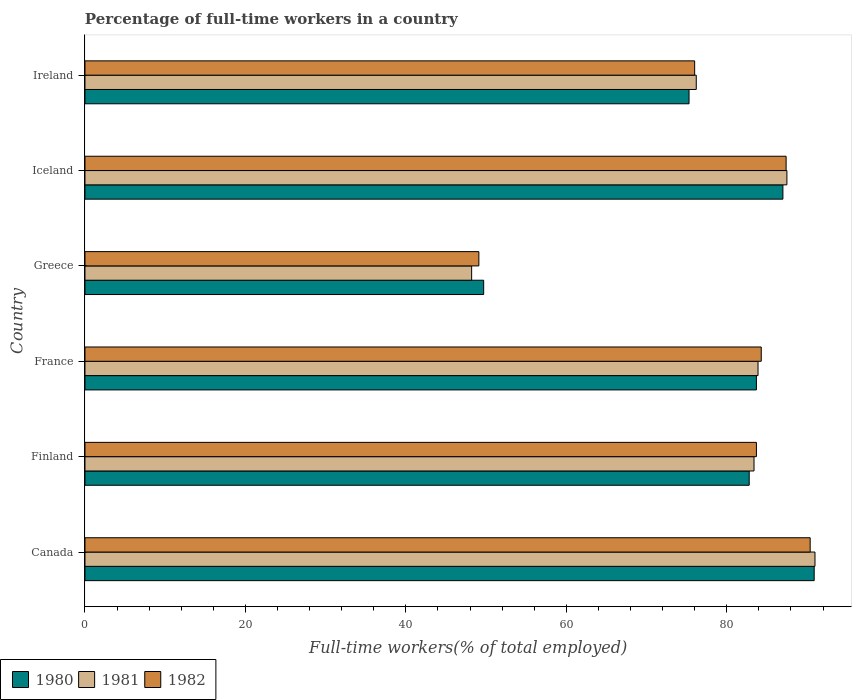How many different coloured bars are there?
Offer a terse response. 3. Are the number of bars per tick equal to the number of legend labels?
Offer a terse response. Yes. Are the number of bars on each tick of the Y-axis equal?
Provide a succinct answer. Yes. How many bars are there on the 1st tick from the top?
Your answer should be very brief. 3. What is the label of the 1st group of bars from the top?
Provide a short and direct response. Ireland. In how many cases, is the number of bars for a given country not equal to the number of legend labels?
Keep it short and to the point. 0. What is the percentage of full-time workers in 1982 in Finland?
Provide a succinct answer. 83.7. Across all countries, what is the maximum percentage of full-time workers in 1982?
Give a very brief answer. 90.4. Across all countries, what is the minimum percentage of full-time workers in 1980?
Offer a terse response. 49.7. In which country was the percentage of full-time workers in 1981 minimum?
Your answer should be very brief. Greece. What is the total percentage of full-time workers in 1982 in the graph?
Offer a very short reply. 470.9. What is the difference between the percentage of full-time workers in 1980 in Greece and that in Ireland?
Your answer should be very brief. -25.6. What is the average percentage of full-time workers in 1981 per country?
Make the answer very short. 78.37. What is the difference between the percentage of full-time workers in 1980 and percentage of full-time workers in 1981 in France?
Offer a very short reply. -0.2. What is the ratio of the percentage of full-time workers in 1981 in France to that in Greece?
Provide a short and direct response. 1.74. Is the percentage of full-time workers in 1980 in Greece less than that in Ireland?
Provide a succinct answer. Yes. What is the difference between the highest and the second highest percentage of full-time workers in 1980?
Your answer should be compact. 3.9. What is the difference between the highest and the lowest percentage of full-time workers in 1981?
Make the answer very short. 42.8. In how many countries, is the percentage of full-time workers in 1982 greater than the average percentage of full-time workers in 1982 taken over all countries?
Offer a very short reply. 4. What does the 1st bar from the bottom in Finland represents?
Provide a succinct answer. 1980. How many bars are there?
Provide a succinct answer. 18. Are all the bars in the graph horizontal?
Your answer should be very brief. Yes. Does the graph contain any zero values?
Ensure brevity in your answer.  No. Does the graph contain grids?
Ensure brevity in your answer.  No. Where does the legend appear in the graph?
Offer a very short reply. Bottom left. How are the legend labels stacked?
Your answer should be compact. Horizontal. What is the title of the graph?
Ensure brevity in your answer.  Percentage of full-time workers in a country. What is the label or title of the X-axis?
Offer a terse response. Full-time workers(% of total employed). What is the label or title of the Y-axis?
Keep it short and to the point. Country. What is the Full-time workers(% of total employed) in 1980 in Canada?
Give a very brief answer. 90.9. What is the Full-time workers(% of total employed) in 1981 in Canada?
Provide a succinct answer. 91. What is the Full-time workers(% of total employed) in 1982 in Canada?
Ensure brevity in your answer.  90.4. What is the Full-time workers(% of total employed) in 1980 in Finland?
Ensure brevity in your answer.  82.8. What is the Full-time workers(% of total employed) in 1981 in Finland?
Make the answer very short. 83.4. What is the Full-time workers(% of total employed) of 1982 in Finland?
Your answer should be very brief. 83.7. What is the Full-time workers(% of total employed) of 1980 in France?
Your response must be concise. 83.7. What is the Full-time workers(% of total employed) in 1981 in France?
Keep it short and to the point. 83.9. What is the Full-time workers(% of total employed) of 1982 in France?
Your answer should be compact. 84.3. What is the Full-time workers(% of total employed) of 1980 in Greece?
Give a very brief answer. 49.7. What is the Full-time workers(% of total employed) in 1981 in Greece?
Your response must be concise. 48.2. What is the Full-time workers(% of total employed) of 1982 in Greece?
Provide a succinct answer. 49.1. What is the Full-time workers(% of total employed) of 1980 in Iceland?
Provide a succinct answer. 87. What is the Full-time workers(% of total employed) in 1981 in Iceland?
Provide a short and direct response. 87.5. What is the Full-time workers(% of total employed) of 1982 in Iceland?
Keep it short and to the point. 87.4. What is the Full-time workers(% of total employed) of 1980 in Ireland?
Keep it short and to the point. 75.3. What is the Full-time workers(% of total employed) in 1981 in Ireland?
Offer a very short reply. 76.2. Across all countries, what is the maximum Full-time workers(% of total employed) in 1980?
Offer a very short reply. 90.9. Across all countries, what is the maximum Full-time workers(% of total employed) in 1981?
Your answer should be compact. 91. Across all countries, what is the maximum Full-time workers(% of total employed) in 1982?
Provide a succinct answer. 90.4. Across all countries, what is the minimum Full-time workers(% of total employed) of 1980?
Give a very brief answer. 49.7. Across all countries, what is the minimum Full-time workers(% of total employed) in 1981?
Keep it short and to the point. 48.2. Across all countries, what is the minimum Full-time workers(% of total employed) of 1982?
Offer a very short reply. 49.1. What is the total Full-time workers(% of total employed) of 1980 in the graph?
Ensure brevity in your answer.  469.4. What is the total Full-time workers(% of total employed) in 1981 in the graph?
Provide a short and direct response. 470.2. What is the total Full-time workers(% of total employed) of 1982 in the graph?
Make the answer very short. 470.9. What is the difference between the Full-time workers(% of total employed) in 1980 in Canada and that in Finland?
Provide a short and direct response. 8.1. What is the difference between the Full-time workers(% of total employed) of 1981 in Canada and that in Finland?
Give a very brief answer. 7.6. What is the difference between the Full-time workers(% of total employed) in 1982 in Canada and that in Finland?
Your response must be concise. 6.7. What is the difference between the Full-time workers(% of total employed) in 1980 in Canada and that in France?
Your answer should be compact. 7.2. What is the difference between the Full-time workers(% of total employed) in 1980 in Canada and that in Greece?
Provide a short and direct response. 41.2. What is the difference between the Full-time workers(% of total employed) of 1981 in Canada and that in Greece?
Provide a short and direct response. 42.8. What is the difference between the Full-time workers(% of total employed) in 1982 in Canada and that in Greece?
Make the answer very short. 41.3. What is the difference between the Full-time workers(% of total employed) in 1981 in Canada and that in Iceland?
Make the answer very short. 3.5. What is the difference between the Full-time workers(% of total employed) in 1982 in Canada and that in Iceland?
Offer a terse response. 3. What is the difference between the Full-time workers(% of total employed) of 1980 in Canada and that in Ireland?
Make the answer very short. 15.6. What is the difference between the Full-time workers(% of total employed) of 1980 in Finland and that in France?
Provide a short and direct response. -0.9. What is the difference between the Full-time workers(% of total employed) of 1981 in Finland and that in France?
Offer a terse response. -0.5. What is the difference between the Full-time workers(% of total employed) of 1980 in Finland and that in Greece?
Your answer should be very brief. 33.1. What is the difference between the Full-time workers(% of total employed) of 1981 in Finland and that in Greece?
Your answer should be compact. 35.2. What is the difference between the Full-time workers(% of total employed) of 1982 in Finland and that in Greece?
Provide a succinct answer. 34.6. What is the difference between the Full-time workers(% of total employed) of 1980 in Finland and that in Iceland?
Make the answer very short. -4.2. What is the difference between the Full-time workers(% of total employed) in 1981 in Finland and that in Iceland?
Provide a short and direct response. -4.1. What is the difference between the Full-time workers(% of total employed) of 1982 in Finland and that in Iceland?
Provide a succinct answer. -3.7. What is the difference between the Full-time workers(% of total employed) of 1981 in Finland and that in Ireland?
Offer a very short reply. 7.2. What is the difference between the Full-time workers(% of total employed) in 1981 in France and that in Greece?
Provide a short and direct response. 35.7. What is the difference between the Full-time workers(% of total employed) of 1982 in France and that in Greece?
Your answer should be compact. 35.2. What is the difference between the Full-time workers(% of total employed) in 1980 in France and that in Iceland?
Keep it short and to the point. -3.3. What is the difference between the Full-time workers(% of total employed) in 1981 in France and that in Iceland?
Give a very brief answer. -3.6. What is the difference between the Full-time workers(% of total employed) of 1980 in France and that in Ireland?
Your response must be concise. 8.4. What is the difference between the Full-time workers(% of total employed) in 1981 in France and that in Ireland?
Give a very brief answer. 7.7. What is the difference between the Full-time workers(% of total employed) in 1982 in France and that in Ireland?
Provide a short and direct response. 8.3. What is the difference between the Full-time workers(% of total employed) in 1980 in Greece and that in Iceland?
Your answer should be very brief. -37.3. What is the difference between the Full-time workers(% of total employed) in 1981 in Greece and that in Iceland?
Give a very brief answer. -39.3. What is the difference between the Full-time workers(% of total employed) of 1982 in Greece and that in Iceland?
Ensure brevity in your answer.  -38.3. What is the difference between the Full-time workers(% of total employed) of 1980 in Greece and that in Ireland?
Ensure brevity in your answer.  -25.6. What is the difference between the Full-time workers(% of total employed) of 1982 in Greece and that in Ireland?
Provide a short and direct response. -26.9. What is the difference between the Full-time workers(% of total employed) of 1980 in Iceland and that in Ireland?
Provide a short and direct response. 11.7. What is the difference between the Full-time workers(% of total employed) of 1982 in Iceland and that in Ireland?
Provide a short and direct response. 11.4. What is the difference between the Full-time workers(% of total employed) of 1981 in Canada and the Full-time workers(% of total employed) of 1982 in Finland?
Provide a succinct answer. 7.3. What is the difference between the Full-time workers(% of total employed) of 1980 in Canada and the Full-time workers(% of total employed) of 1982 in France?
Your response must be concise. 6.6. What is the difference between the Full-time workers(% of total employed) of 1981 in Canada and the Full-time workers(% of total employed) of 1982 in France?
Offer a very short reply. 6.7. What is the difference between the Full-time workers(% of total employed) of 1980 in Canada and the Full-time workers(% of total employed) of 1981 in Greece?
Offer a very short reply. 42.7. What is the difference between the Full-time workers(% of total employed) in 1980 in Canada and the Full-time workers(% of total employed) in 1982 in Greece?
Offer a very short reply. 41.8. What is the difference between the Full-time workers(% of total employed) in 1981 in Canada and the Full-time workers(% of total employed) in 1982 in Greece?
Make the answer very short. 41.9. What is the difference between the Full-time workers(% of total employed) in 1980 in Canada and the Full-time workers(% of total employed) in 1981 in Iceland?
Your answer should be compact. 3.4. What is the difference between the Full-time workers(% of total employed) in 1981 in Canada and the Full-time workers(% of total employed) in 1982 in Iceland?
Provide a succinct answer. 3.6. What is the difference between the Full-time workers(% of total employed) in 1980 in Canada and the Full-time workers(% of total employed) in 1982 in Ireland?
Your answer should be very brief. 14.9. What is the difference between the Full-time workers(% of total employed) in 1981 in Canada and the Full-time workers(% of total employed) in 1982 in Ireland?
Your response must be concise. 15. What is the difference between the Full-time workers(% of total employed) in 1980 in Finland and the Full-time workers(% of total employed) in 1981 in Greece?
Ensure brevity in your answer.  34.6. What is the difference between the Full-time workers(% of total employed) of 1980 in Finland and the Full-time workers(% of total employed) of 1982 in Greece?
Make the answer very short. 33.7. What is the difference between the Full-time workers(% of total employed) of 1981 in Finland and the Full-time workers(% of total employed) of 1982 in Greece?
Your answer should be compact. 34.3. What is the difference between the Full-time workers(% of total employed) in 1980 in Finland and the Full-time workers(% of total employed) in 1981 in Iceland?
Offer a very short reply. -4.7. What is the difference between the Full-time workers(% of total employed) of 1980 in Finland and the Full-time workers(% of total employed) of 1982 in Iceland?
Give a very brief answer. -4.6. What is the difference between the Full-time workers(% of total employed) of 1980 in France and the Full-time workers(% of total employed) of 1981 in Greece?
Keep it short and to the point. 35.5. What is the difference between the Full-time workers(% of total employed) of 1980 in France and the Full-time workers(% of total employed) of 1982 in Greece?
Offer a very short reply. 34.6. What is the difference between the Full-time workers(% of total employed) in 1981 in France and the Full-time workers(% of total employed) in 1982 in Greece?
Offer a very short reply. 34.8. What is the difference between the Full-time workers(% of total employed) of 1980 in France and the Full-time workers(% of total employed) of 1981 in Iceland?
Keep it short and to the point. -3.8. What is the difference between the Full-time workers(% of total employed) of 1980 in France and the Full-time workers(% of total employed) of 1982 in Iceland?
Provide a succinct answer. -3.7. What is the difference between the Full-time workers(% of total employed) in 1980 in France and the Full-time workers(% of total employed) in 1981 in Ireland?
Your answer should be compact. 7.5. What is the difference between the Full-time workers(% of total employed) of 1980 in Greece and the Full-time workers(% of total employed) of 1981 in Iceland?
Keep it short and to the point. -37.8. What is the difference between the Full-time workers(% of total employed) in 1980 in Greece and the Full-time workers(% of total employed) in 1982 in Iceland?
Offer a terse response. -37.7. What is the difference between the Full-time workers(% of total employed) of 1981 in Greece and the Full-time workers(% of total employed) of 1982 in Iceland?
Offer a very short reply. -39.2. What is the difference between the Full-time workers(% of total employed) in 1980 in Greece and the Full-time workers(% of total employed) in 1981 in Ireland?
Offer a very short reply. -26.5. What is the difference between the Full-time workers(% of total employed) in 1980 in Greece and the Full-time workers(% of total employed) in 1982 in Ireland?
Give a very brief answer. -26.3. What is the difference between the Full-time workers(% of total employed) of 1981 in Greece and the Full-time workers(% of total employed) of 1982 in Ireland?
Offer a terse response. -27.8. What is the difference between the Full-time workers(% of total employed) in 1980 in Iceland and the Full-time workers(% of total employed) in 1982 in Ireland?
Give a very brief answer. 11. What is the difference between the Full-time workers(% of total employed) of 1981 in Iceland and the Full-time workers(% of total employed) of 1982 in Ireland?
Give a very brief answer. 11.5. What is the average Full-time workers(% of total employed) of 1980 per country?
Give a very brief answer. 78.23. What is the average Full-time workers(% of total employed) in 1981 per country?
Offer a terse response. 78.37. What is the average Full-time workers(% of total employed) in 1982 per country?
Ensure brevity in your answer.  78.48. What is the difference between the Full-time workers(% of total employed) in 1980 and Full-time workers(% of total employed) in 1982 in Canada?
Give a very brief answer. 0.5. What is the difference between the Full-time workers(% of total employed) in 1981 and Full-time workers(% of total employed) in 1982 in Finland?
Provide a succinct answer. -0.3. What is the difference between the Full-time workers(% of total employed) in 1980 and Full-time workers(% of total employed) in 1981 in France?
Your answer should be very brief. -0.2. What is the difference between the Full-time workers(% of total employed) in 1981 and Full-time workers(% of total employed) in 1982 in France?
Offer a terse response. -0.4. What is the difference between the Full-time workers(% of total employed) of 1980 and Full-time workers(% of total employed) of 1981 in Iceland?
Provide a short and direct response. -0.5. What is the difference between the Full-time workers(% of total employed) of 1980 and Full-time workers(% of total employed) of 1982 in Iceland?
Your response must be concise. -0.4. What is the difference between the Full-time workers(% of total employed) in 1981 and Full-time workers(% of total employed) in 1982 in Iceland?
Give a very brief answer. 0.1. What is the difference between the Full-time workers(% of total employed) of 1980 and Full-time workers(% of total employed) of 1981 in Ireland?
Provide a short and direct response. -0.9. What is the difference between the Full-time workers(% of total employed) in 1981 and Full-time workers(% of total employed) in 1982 in Ireland?
Your answer should be compact. 0.2. What is the ratio of the Full-time workers(% of total employed) of 1980 in Canada to that in Finland?
Offer a terse response. 1.1. What is the ratio of the Full-time workers(% of total employed) in 1981 in Canada to that in Finland?
Offer a terse response. 1.09. What is the ratio of the Full-time workers(% of total employed) in 1980 in Canada to that in France?
Make the answer very short. 1.09. What is the ratio of the Full-time workers(% of total employed) of 1981 in Canada to that in France?
Your answer should be very brief. 1.08. What is the ratio of the Full-time workers(% of total employed) of 1982 in Canada to that in France?
Provide a succinct answer. 1.07. What is the ratio of the Full-time workers(% of total employed) of 1980 in Canada to that in Greece?
Offer a very short reply. 1.83. What is the ratio of the Full-time workers(% of total employed) of 1981 in Canada to that in Greece?
Provide a short and direct response. 1.89. What is the ratio of the Full-time workers(% of total employed) of 1982 in Canada to that in Greece?
Your answer should be very brief. 1.84. What is the ratio of the Full-time workers(% of total employed) in 1980 in Canada to that in Iceland?
Provide a succinct answer. 1.04. What is the ratio of the Full-time workers(% of total employed) in 1982 in Canada to that in Iceland?
Your answer should be very brief. 1.03. What is the ratio of the Full-time workers(% of total employed) of 1980 in Canada to that in Ireland?
Offer a very short reply. 1.21. What is the ratio of the Full-time workers(% of total employed) of 1981 in Canada to that in Ireland?
Ensure brevity in your answer.  1.19. What is the ratio of the Full-time workers(% of total employed) in 1982 in Canada to that in Ireland?
Make the answer very short. 1.19. What is the ratio of the Full-time workers(% of total employed) in 1981 in Finland to that in France?
Give a very brief answer. 0.99. What is the ratio of the Full-time workers(% of total employed) of 1980 in Finland to that in Greece?
Give a very brief answer. 1.67. What is the ratio of the Full-time workers(% of total employed) in 1981 in Finland to that in Greece?
Your answer should be very brief. 1.73. What is the ratio of the Full-time workers(% of total employed) in 1982 in Finland to that in Greece?
Keep it short and to the point. 1.7. What is the ratio of the Full-time workers(% of total employed) in 1980 in Finland to that in Iceland?
Give a very brief answer. 0.95. What is the ratio of the Full-time workers(% of total employed) of 1981 in Finland to that in Iceland?
Give a very brief answer. 0.95. What is the ratio of the Full-time workers(% of total employed) in 1982 in Finland to that in Iceland?
Provide a short and direct response. 0.96. What is the ratio of the Full-time workers(% of total employed) of 1980 in Finland to that in Ireland?
Provide a succinct answer. 1.1. What is the ratio of the Full-time workers(% of total employed) in 1981 in Finland to that in Ireland?
Make the answer very short. 1.09. What is the ratio of the Full-time workers(% of total employed) in 1982 in Finland to that in Ireland?
Provide a short and direct response. 1.1. What is the ratio of the Full-time workers(% of total employed) of 1980 in France to that in Greece?
Your answer should be very brief. 1.68. What is the ratio of the Full-time workers(% of total employed) of 1981 in France to that in Greece?
Provide a short and direct response. 1.74. What is the ratio of the Full-time workers(% of total employed) in 1982 in France to that in Greece?
Offer a terse response. 1.72. What is the ratio of the Full-time workers(% of total employed) in 1980 in France to that in Iceland?
Your response must be concise. 0.96. What is the ratio of the Full-time workers(% of total employed) of 1981 in France to that in Iceland?
Offer a terse response. 0.96. What is the ratio of the Full-time workers(% of total employed) in 1982 in France to that in Iceland?
Offer a terse response. 0.96. What is the ratio of the Full-time workers(% of total employed) of 1980 in France to that in Ireland?
Make the answer very short. 1.11. What is the ratio of the Full-time workers(% of total employed) of 1981 in France to that in Ireland?
Provide a succinct answer. 1.1. What is the ratio of the Full-time workers(% of total employed) of 1982 in France to that in Ireland?
Your answer should be compact. 1.11. What is the ratio of the Full-time workers(% of total employed) of 1980 in Greece to that in Iceland?
Make the answer very short. 0.57. What is the ratio of the Full-time workers(% of total employed) of 1981 in Greece to that in Iceland?
Make the answer very short. 0.55. What is the ratio of the Full-time workers(% of total employed) of 1982 in Greece to that in Iceland?
Your answer should be very brief. 0.56. What is the ratio of the Full-time workers(% of total employed) in 1980 in Greece to that in Ireland?
Your answer should be very brief. 0.66. What is the ratio of the Full-time workers(% of total employed) in 1981 in Greece to that in Ireland?
Offer a very short reply. 0.63. What is the ratio of the Full-time workers(% of total employed) of 1982 in Greece to that in Ireland?
Your response must be concise. 0.65. What is the ratio of the Full-time workers(% of total employed) in 1980 in Iceland to that in Ireland?
Offer a terse response. 1.16. What is the ratio of the Full-time workers(% of total employed) of 1981 in Iceland to that in Ireland?
Your response must be concise. 1.15. What is the ratio of the Full-time workers(% of total employed) of 1982 in Iceland to that in Ireland?
Make the answer very short. 1.15. What is the difference between the highest and the second highest Full-time workers(% of total employed) of 1980?
Your response must be concise. 3.9. What is the difference between the highest and the second highest Full-time workers(% of total employed) in 1982?
Offer a terse response. 3. What is the difference between the highest and the lowest Full-time workers(% of total employed) in 1980?
Offer a terse response. 41.2. What is the difference between the highest and the lowest Full-time workers(% of total employed) of 1981?
Your answer should be compact. 42.8. What is the difference between the highest and the lowest Full-time workers(% of total employed) of 1982?
Offer a terse response. 41.3. 